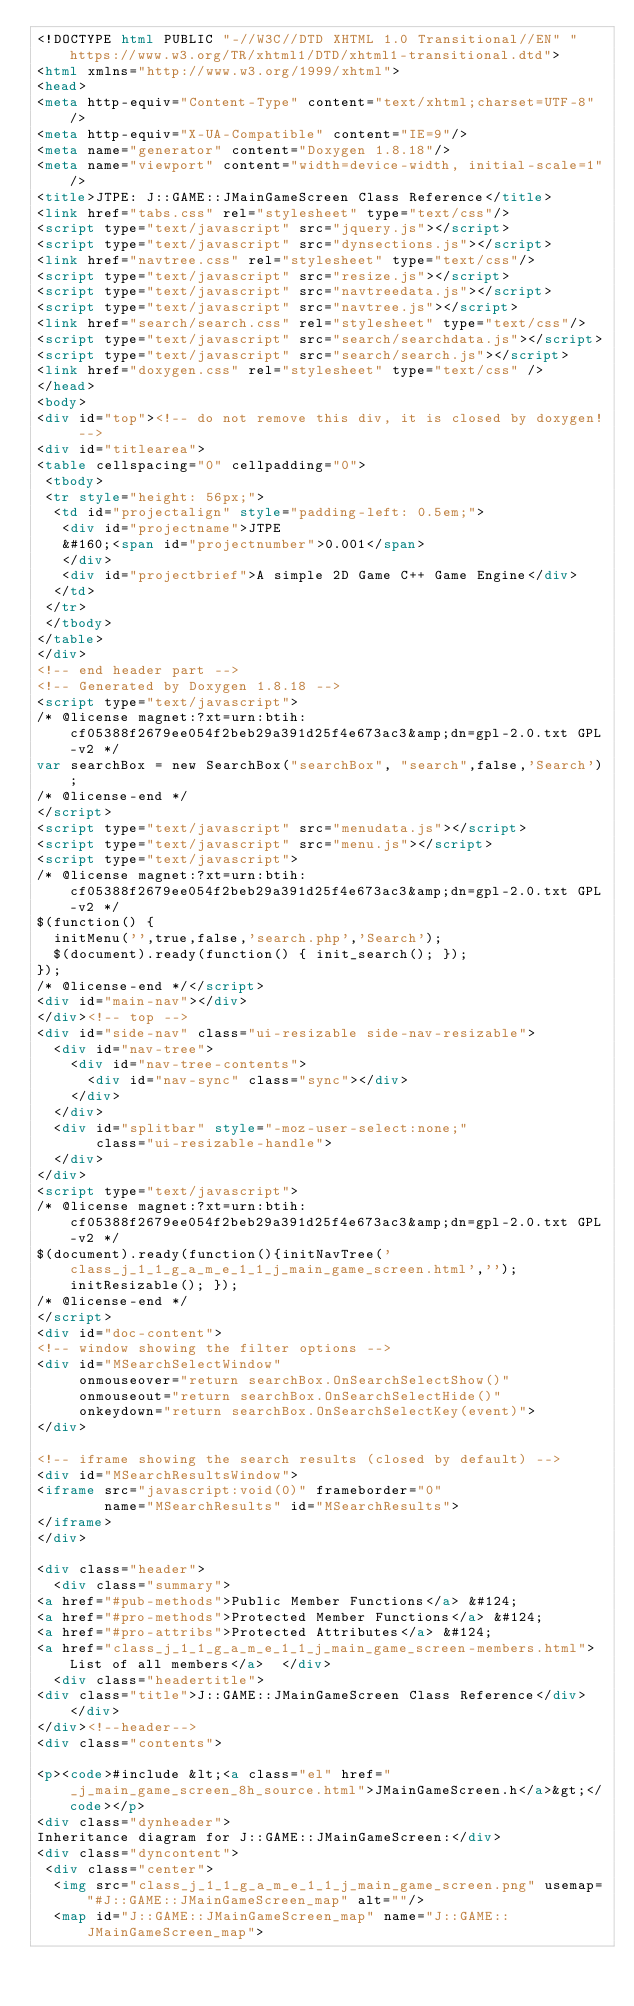<code> <loc_0><loc_0><loc_500><loc_500><_HTML_><!DOCTYPE html PUBLIC "-//W3C//DTD XHTML 1.0 Transitional//EN" "https://www.w3.org/TR/xhtml1/DTD/xhtml1-transitional.dtd">
<html xmlns="http://www.w3.org/1999/xhtml">
<head>
<meta http-equiv="Content-Type" content="text/xhtml;charset=UTF-8"/>
<meta http-equiv="X-UA-Compatible" content="IE=9"/>
<meta name="generator" content="Doxygen 1.8.18"/>
<meta name="viewport" content="width=device-width, initial-scale=1"/>
<title>JTPE: J::GAME::JMainGameScreen Class Reference</title>
<link href="tabs.css" rel="stylesheet" type="text/css"/>
<script type="text/javascript" src="jquery.js"></script>
<script type="text/javascript" src="dynsections.js"></script>
<link href="navtree.css" rel="stylesheet" type="text/css"/>
<script type="text/javascript" src="resize.js"></script>
<script type="text/javascript" src="navtreedata.js"></script>
<script type="text/javascript" src="navtree.js"></script>
<link href="search/search.css" rel="stylesheet" type="text/css"/>
<script type="text/javascript" src="search/searchdata.js"></script>
<script type="text/javascript" src="search/search.js"></script>
<link href="doxygen.css" rel="stylesheet" type="text/css" />
</head>
<body>
<div id="top"><!-- do not remove this div, it is closed by doxygen! -->
<div id="titlearea">
<table cellspacing="0" cellpadding="0">
 <tbody>
 <tr style="height: 56px;">
  <td id="projectalign" style="padding-left: 0.5em;">
   <div id="projectname">JTPE
   &#160;<span id="projectnumber">0.001</span>
   </div>
   <div id="projectbrief">A simple 2D Game C++ Game Engine</div>
  </td>
 </tr>
 </tbody>
</table>
</div>
<!-- end header part -->
<!-- Generated by Doxygen 1.8.18 -->
<script type="text/javascript">
/* @license magnet:?xt=urn:btih:cf05388f2679ee054f2beb29a391d25f4e673ac3&amp;dn=gpl-2.0.txt GPL-v2 */
var searchBox = new SearchBox("searchBox", "search",false,'Search');
/* @license-end */
</script>
<script type="text/javascript" src="menudata.js"></script>
<script type="text/javascript" src="menu.js"></script>
<script type="text/javascript">
/* @license magnet:?xt=urn:btih:cf05388f2679ee054f2beb29a391d25f4e673ac3&amp;dn=gpl-2.0.txt GPL-v2 */
$(function() {
  initMenu('',true,false,'search.php','Search');
  $(document).ready(function() { init_search(); });
});
/* @license-end */</script>
<div id="main-nav"></div>
</div><!-- top -->
<div id="side-nav" class="ui-resizable side-nav-resizable">
  <div id="nav-tree">
    <div id="nav-tree-contents">
      <div id="nav-sync" class="sync"></div>
    </div>
  </div>
  <div id="splitbar" style="-moz-user-select:none;" 
       class="ui-resizable-handle">
  </div>
</div>
<script type="text/javascript">
/* @license magnet:?xt=urn:btih:cf05388f2679ee054f2beb29a391d25f4e673ac3&amp;dn=gpl-2.0.txt GPL-v2 */
$(document).ready(function(){initNavTree('class_j_1_1_g_a_m_e_1_1_j_main_game_screen.html',''); initResizable(); });
/* @license-end */
</script>
<div id="doc-content">
<!-- window showing the filter options -->
<div id="MSearchSelectWindow"
     onmouseover="return searchBox.OnSearchSelectShow()"
     onmouseout="return searchBox.OnSearchSelectHide()"
     onkeydown="return searchBox.OnSearchSelectKey(event)">
</div>

<!-- iframe showing the search results (closed by default) -->
<div id="MSearchResultsWindow">
<iframe src="javascript:void(0)" frameborder="0" 
        name="MSearchResults" id="MSearchResults">
</iframe>
</div>

<div class="header">
  <div class="summary">
<a href="#pub-methods">Public Member Functions</a> &#124;
<a href="#pro-methods">Protected Member Functions</a> &#124;
<a href="#pro-attribs">Protected Attributes</a> &#124;
<a href="class_j_1_1_g_a_m_e_1_1_j_main_game_screen-members.html">List of all members</a>  </div>
  <div class="headertitle">
<div class="title">J::GAME::JMainGameScreen Class Reference</div>  </div>
</div><!--header-->
<div class="contents">

<p><code>#include &lt;<a class="el" href="_j_main_game_screen_8h_source.html">JMainGameScreen.h</a>&gt;</code></p>
<div class="dynheader">
Inheritance diagram for J::GAME::JMainGameScreen:</div>
<div class="dyncontent">
 <div class="center">
  <img src="class_j_1_1_g_a_m_e_1_1_j_main_game_screen.png" usemap="#J::GAME::JMainGameScreen_map" alt=""/>
  <map id="J::GAME::JMainGameScreen_map" name="J::GAME::JMainGameScreen_map"></code> 